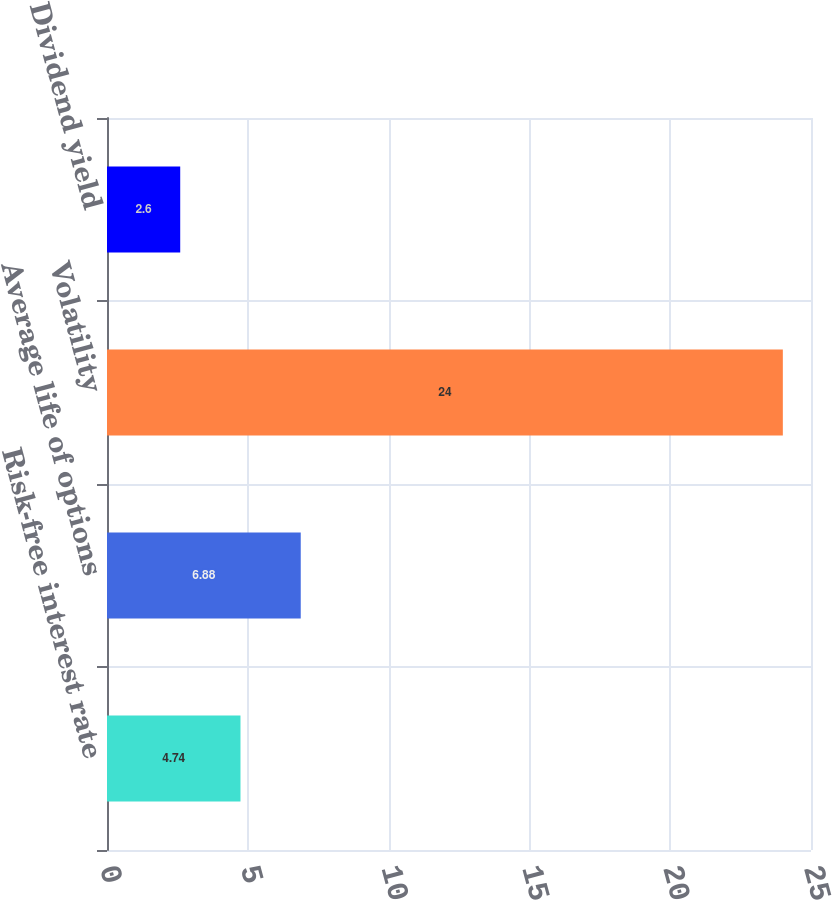Convert chart to OTSL. <chart><loc_0><loc_0><loc_500><loc_500><bar_chart><fcel>Risk-free interest rate<fcel>Average life of options<fcel>Volatility<fcel>Dividend yield<nl><fcel>4.74<fcel>6.88<fcel>24<fcel>2.6<nl></chart> 